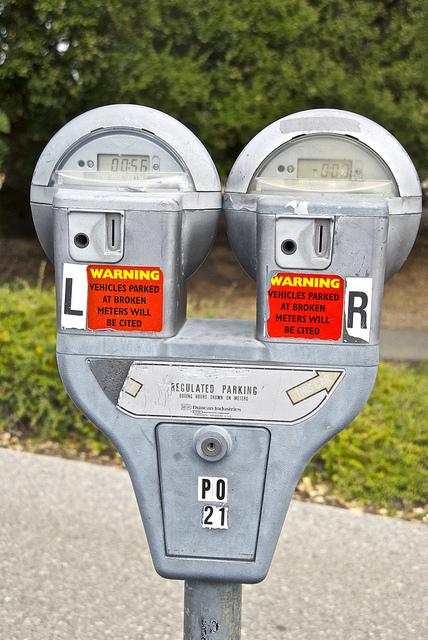Is it okay to park at a broken meter?
Short answer required. No. Is there time on the meter?
Quick response, please. Yes. What is the color of the parking meter?
Short answer required. Gray. 